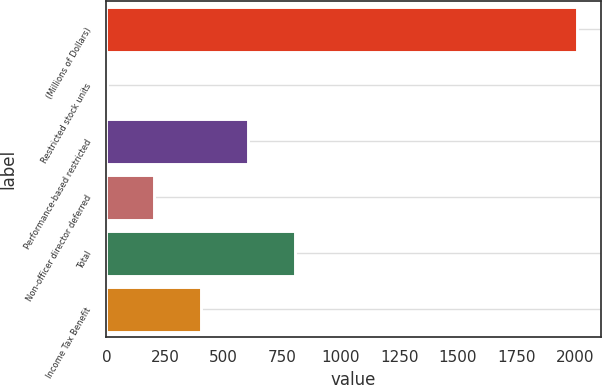Convert chart to OTSL. <chart><loc_0><loc_0><loc_500><loc_500><bar_chart><fcel>(Millions of Dollars)<fcel>Restricted stock units<fcel>Performance-based restricted<fcel>Non-officer director deferred<fcel>Total<fcel>Income Tax Benefit<nl><fcel>2009<fcel>1<fcel>603.4<fcel>201.8<fcel>804.2<fcel>402.6<nl></chart> 